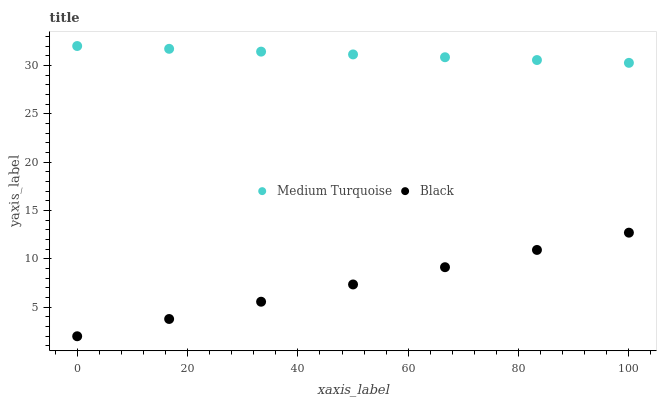Does Black have the minimum area under the curve?
Answer yes or no. Yes. Does Medium Turquoise have the maximum area under the curve?
Answer yes or no. Yes. Does Medium Turquoise have the minimum area under the curve?
Answer yes or no. No. Is Black the smoothest?
Answer yes or no. Yes. Is Medium Turquoise the roughest?
Answer yes or no. Yes. Is Medium Turquoise the smoothest?
Answer yes or no. No. Does Black have the lowest value?
Answer yes or no. Yes. Does Medium Turquoise have the lowest value?
Answer yes or no. No. Does Medium Turquoise have the highest value?
Answer yes or no. Yes. Is Black less than Medium Turquoise?
Answer yes or no. Yes. Is Medium Turquoise greater than Black?
Answer yes or no. Yes. Does Black intersect Medium Turquoise?
Answer yes or no. No. 